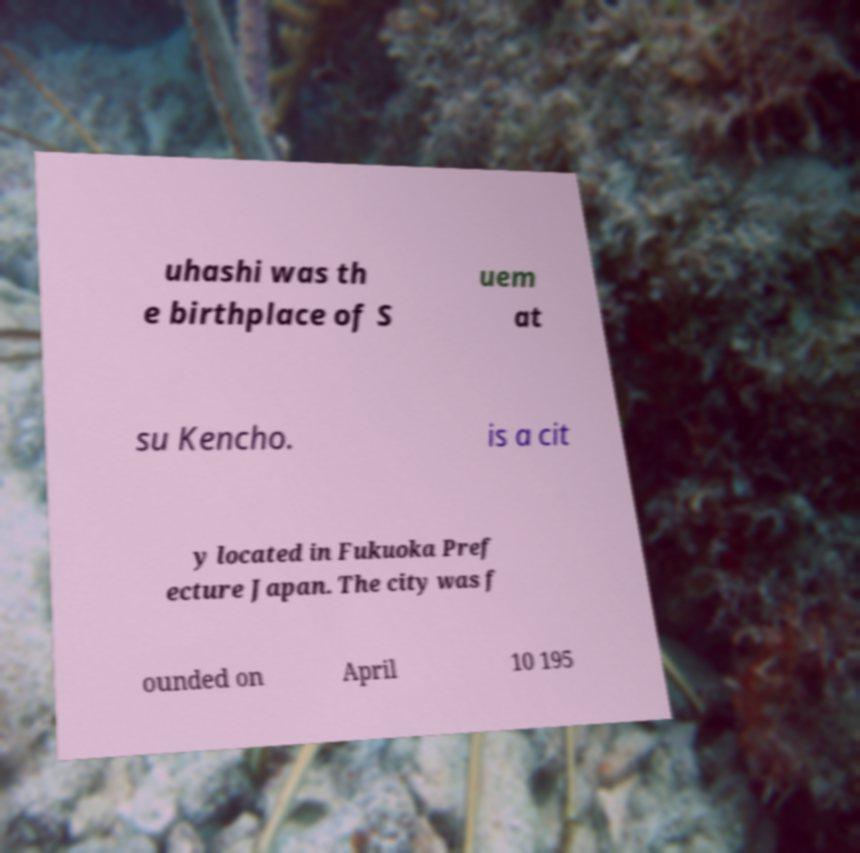Please read and relay the text visible in this image. What does it say? uhashi was th e birthplace of S uem at su Kencho. is a cit y located in Fukuoka Pref ecture Japan. The city was f ounded on April 10 195 